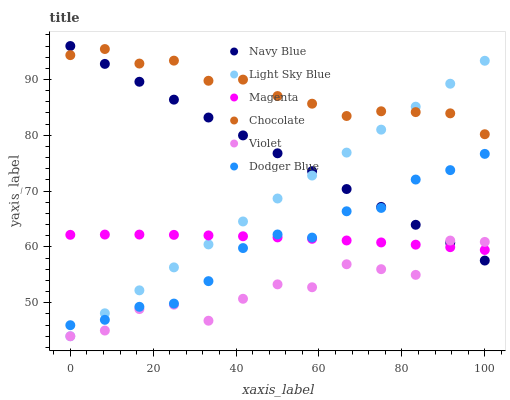Does Violet have the minimum area under the curve?
Answer yes or no. Yes. Does Chocolate have the maximum area under the curve?
Answer yes or no. Yes. Does Light Sky Blue have the minimum area under the curve?
Answer yes or no. No. Does Light Sky Blue have the maximum area under the curve?
Answer yes or no. No. Is Navy Blue the smoothest?
Answer yes or no. Yes. Is Violet the roughest?
Answer yes or no. Yes. Is Chocolate the smoothest?
Answer yes or no. No. Is Chocolate the roughest?
Answer yes or no. No. Does Light Sky Blue have the lowest value?
Answer yes or no. Yes. Does Chocolate have the lowest value?
Answer yes or no. No. Does Navy Blue have the highest value?
Answer yes or no. Yes. Does Chocolate have the highest value?
Answer yes or no. No. Is Dodger Blue less than Chocolate?
Answer yes or no. Yes. Is Chocolate greater than Magenta?
Answer yes or no. Yes. Does Magenta intersect Dodger Blue?
Answer yes or no. Yes. Is Magenta less than Dodger Blue?
Answer yes or no. No. Is Magenta greater than Dodger Blue?
Answer yes or no. No. Does Dodger Blue intersect Chocolate?
Answer yes or no. No. 